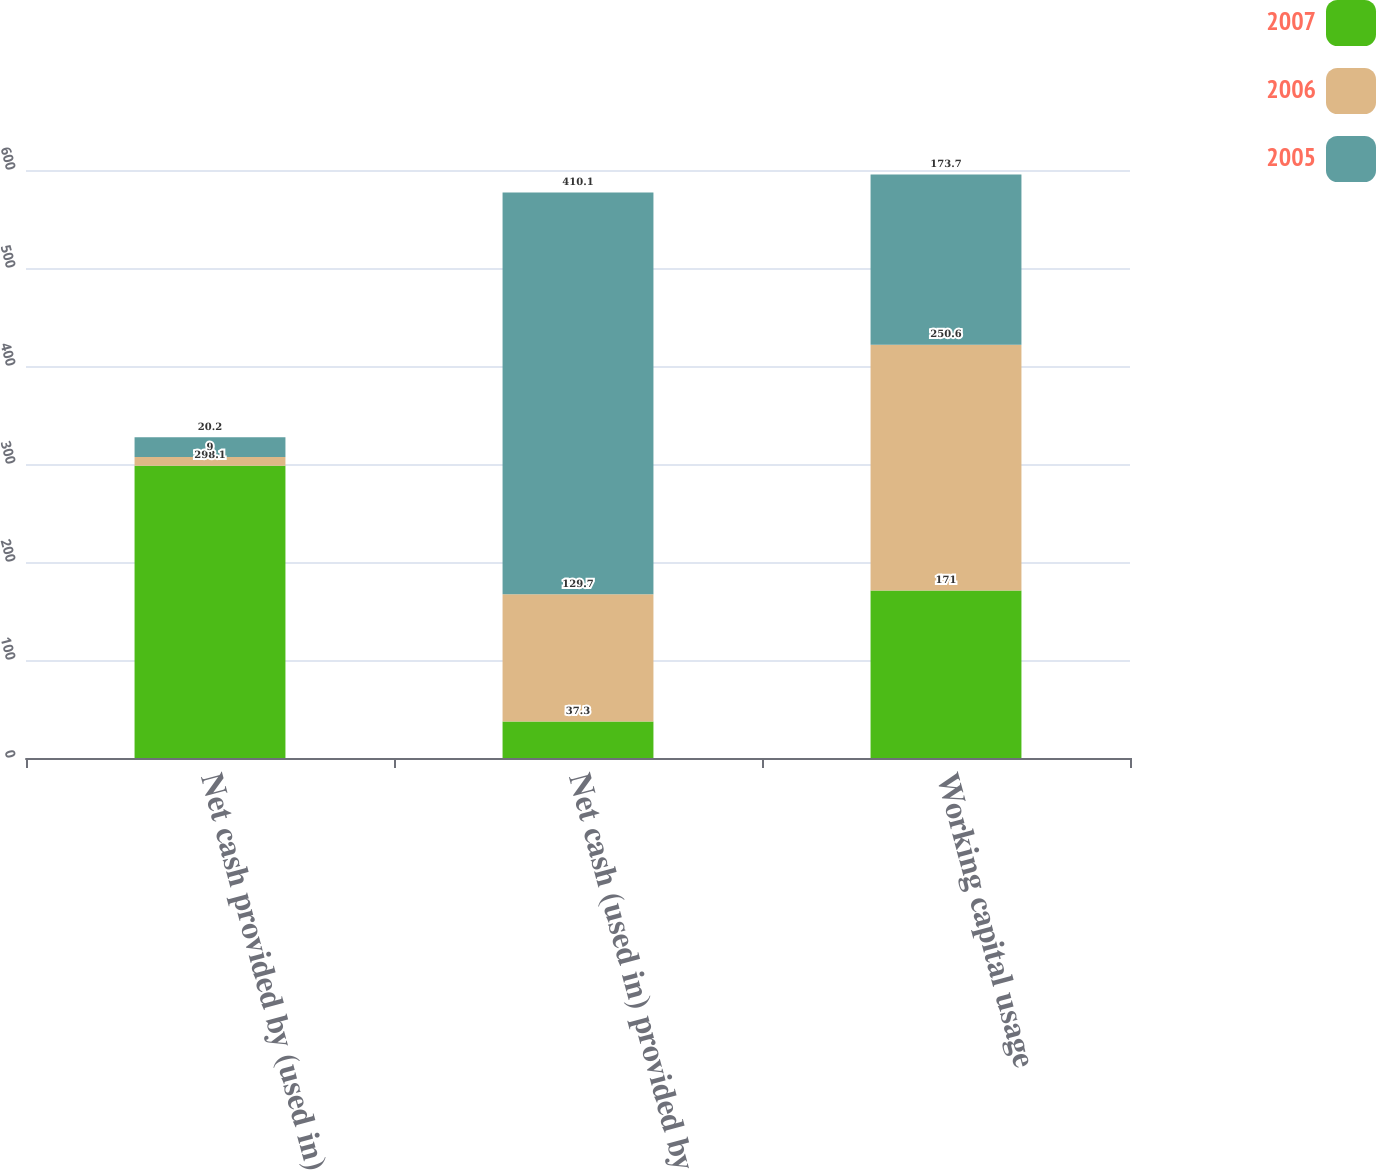<chart> <loc_0><loc_0><loc_500><loc_500><stacked_bar_chart><ecel><fcel>Net cash provided by (used in)<fcel>Net cash (used in) provided by<fcel>Working capital usage<nl><fcel>2007<fcel>298.1<fcel>37.3<fcel>171<nl><fcel>2006<fcel>9<fcel>129.7<fcel>250.6<nl><fcel>2005<fcel>20.2<fcel>410.1<fcel>173.7<nl></chart> 